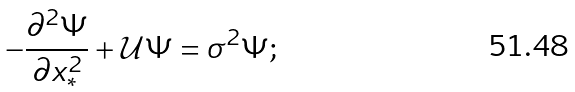<formula> <loc_0><loc_0><loc_500><loc_500>- \frac { \partial ^ { 2 } \Psi } { \partial x _ { * } ^ { 2 } } + { \mathcal { U } } \Psi = \sigma ^ { 2 } \Psi ;</formula> 